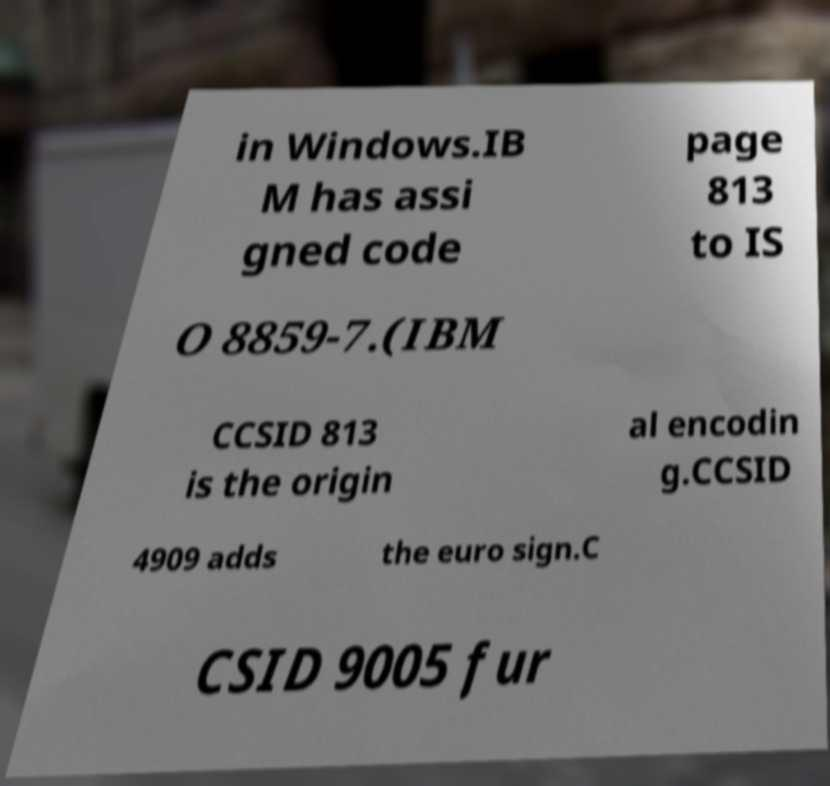What messages or text are displayed in this image? I need them in a readable, typed format. in Windows.IB M has assi gned code page 813 to IS O 8859-7.(IBM CCSID 813 is the origin al encodin g.CCSID 4909 adds the euro sign.C CSID 9005 fur 